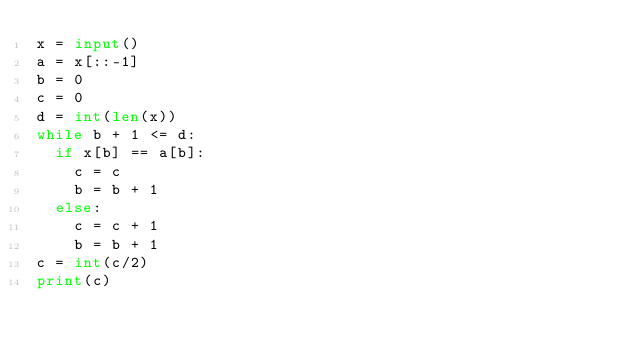Convert code to text. <code><loc_0><loc_0><loc_500><loc_500><_Python_>x = input()
a = x[::-1]
b = 0
c = 0
d = int(len(x))
while b + 1 <= d:
  if x[b] == a[b]:
    c = c
    b = b + 1
  else:
    c = c + 1
    b = b + 1
c = int(c/2)
print(c)</code> 